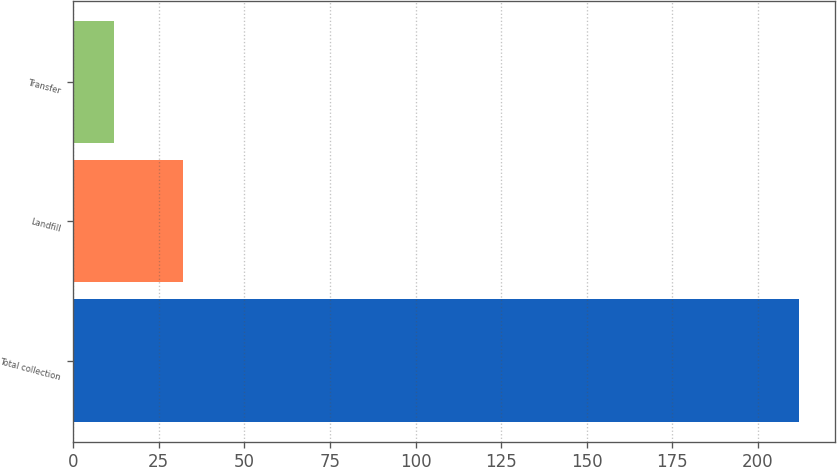<chart> <loc_0><loc_0><loc_500><loc_500><bar_chart><fcel>Total collection<fcel>Landfill<fcel>Transfer<nl><fcel>212<fcel>32<fcel>12<nl></chart> 